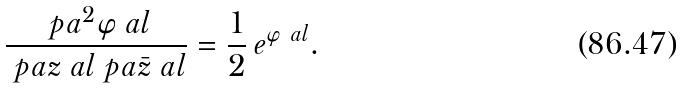Convert formula to latex. <formula><loc_0><loc_0><loc_500><loc_500>\frac { \ p a ^ { 2 } \varphi _ { \ } a l } { \ p a z _ { \ } a l \ p a \bar { z } _ { \ } a l } = \frac { 1 } { 2 } \, e ^ { \varphi _ { \ } a l } .</formula> 